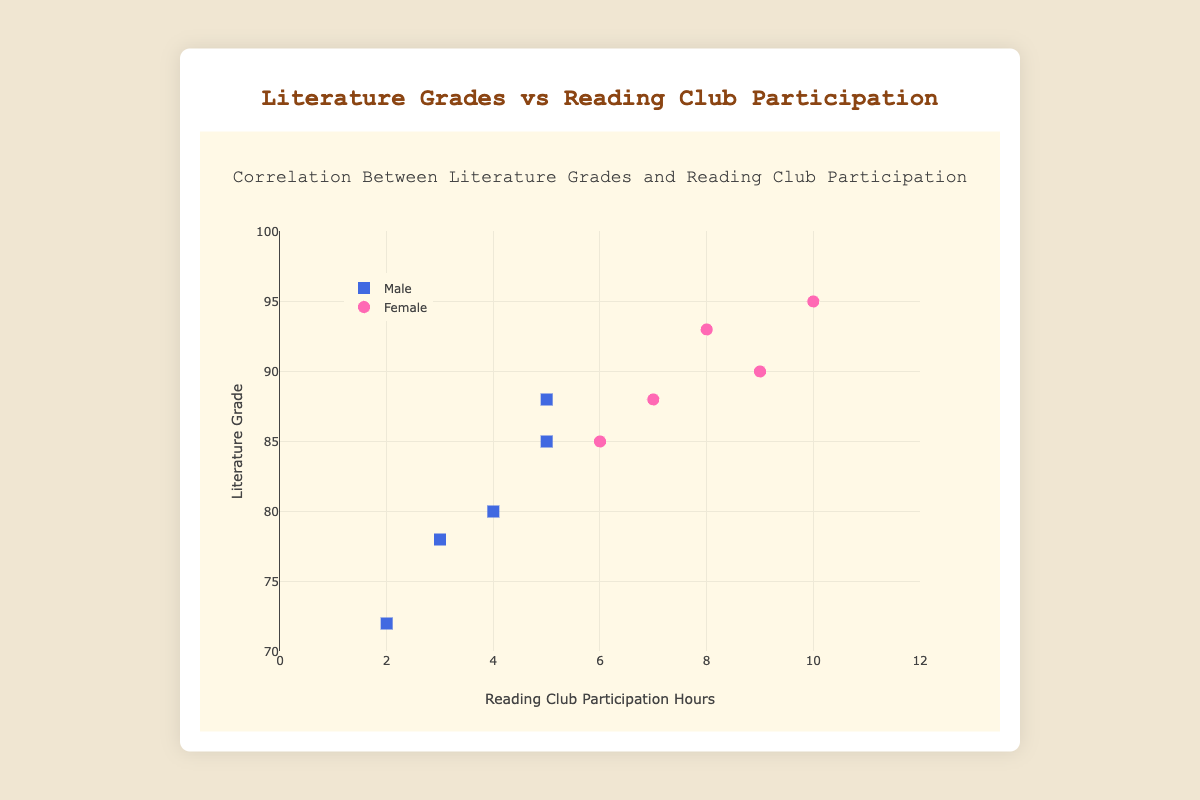How many female students are represented in the plot? By counting the data points (markers) for female students (pink circles), we see there are 5 such points.
Answer: 5 What is the maximum reading club participation hours recorded by a male student? Scan the x-axis positions for male data points (blue squares). The highest x-value for males is 5 hours.
Answer: 5 What is the average literature grade for female students who participated more than 7 hours in reading clubs? Identify female data points with more than 7 hours (pink circles at x=9 and x=10). Their grades are 90 and 95. Average these grades: (90 + 95)/2 = 92.5
Answer: 92.5 Compare the literature grades of male and female students with exactly 5 hours of reading club participation. Who scored higher? Find matching x=5 data points: male (85 and 88) and female (none). The highest grade among males is 88, and there are no females with exactly 5 hours.
Answer: Male, 88 Do a specific gender’s literature grades correlationally increase with reading club hours? Looking at the trend line through male (blue squares) and female (pink circles) data, we observe that female students generally show an increase in grades with participation, unlike males who show no clear pattern.
Answer: Females What is the difference between the highest literature grades by gender? The highest grade for females is 95 and for males is 88. The difference is 95 - 88 = 7.
Answer: 7 For both genders, what is the total number of data points shown in the figure? Counting all data points, we have 10 points total: 5 male (blue squares) and 5 female (pink circles).
Answer: 10 Which axis represents reading club participation hours, and what range does it cover? The x-axis represents reading club participation hours, ranging from 0 to 12 hours. The y-axis represents the literature grade, ranging from 70 to 100.
Answer: x-axis, 0-12 Identify the student with the lowest literature grade and their reading club participation hours. The lowest literature grade is 72 (male student “S006”), with 2 hours of reading club participation.
Answer: S006, 2 hours What is the median literature grade for male students? Arrange male literature grades (85, 78, 72, 80, 88) in ascending order: 72, 78, 80, 85, 88. The median grade is the middle value, 80.
Answer: 80 